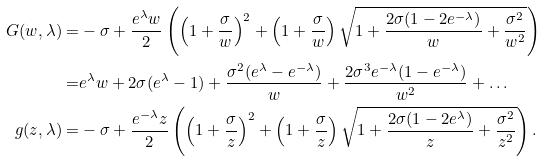Convert formula to latex. <formula><loc_0><loc_0><loc_500><loc_500>G ( w , \lambda ) = & - \sigma + \frac { e ^ { \lambda } w } { 2 } \left ( \left ( 1 + \frac { \sigma } { w } \right ) ^ { 2 } + \left ( 1 + \frac { \sigma } { w } \right ) \sqrt { 1 + \frac { 2 \sigma ( 1 - 2 e ^ { - \lambda } ) } { w } + \frac { \sigma ^ { 2 } } { w ^ { 2 } } } \right ) \\ = & e ^ { \lambda } w + 2 \sigma ( e ^ { \lambda } - 1 ) + \frac { \sigma ^ { 2 } ( e ^ { \lambda } - e ^ { - \lambda } ) } { w } + \frac { 2 \sigma ^ { 3 } e ^ { - \lambda } ( 1 - e ^ { - \lambda } ) } { w ^ { 2 } } + \dots \\ g ( z , \lambda ) = & - \sigma + \frac { e ^ { - \lambda } z } { 2 } \left ( \left ( 1 + \frac { \sigma } { z } \right ) ^ { 2 } + \left ( 1 + \frac { \sigma } { z } \right ) \sqrt { 1 + \frac { 2 \sigma ( 1 - 2 e ^ { \lambda } ) } { z } + \frac { \sigma ^ { 2 } } { z ^ { 2 } } } \right ) .</formula> 